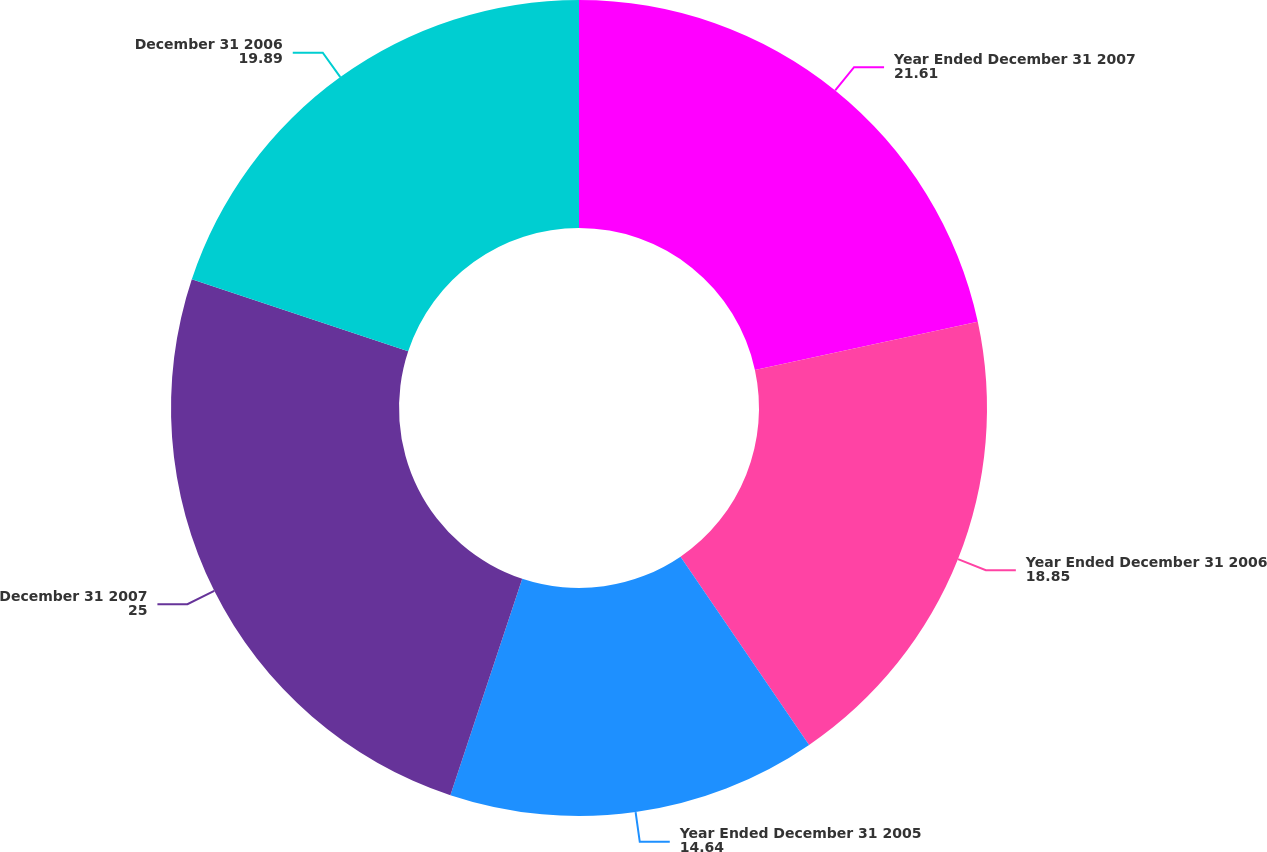Convert chart. <chart><loc_0><loc_0><loc_500><loc_500><pie_chart><fcel>Year Ended December 31 2007<fcel>Year Ended December 31 2006<fcel>Year Ended December 31 2005<fcel>December 31 2007<fcel>December 31 2006<nl><fcel>21.61%<fcel>18.85%<fcel>14.64%<fcel>25.0%<fcel>19.89%<nl></chart> 